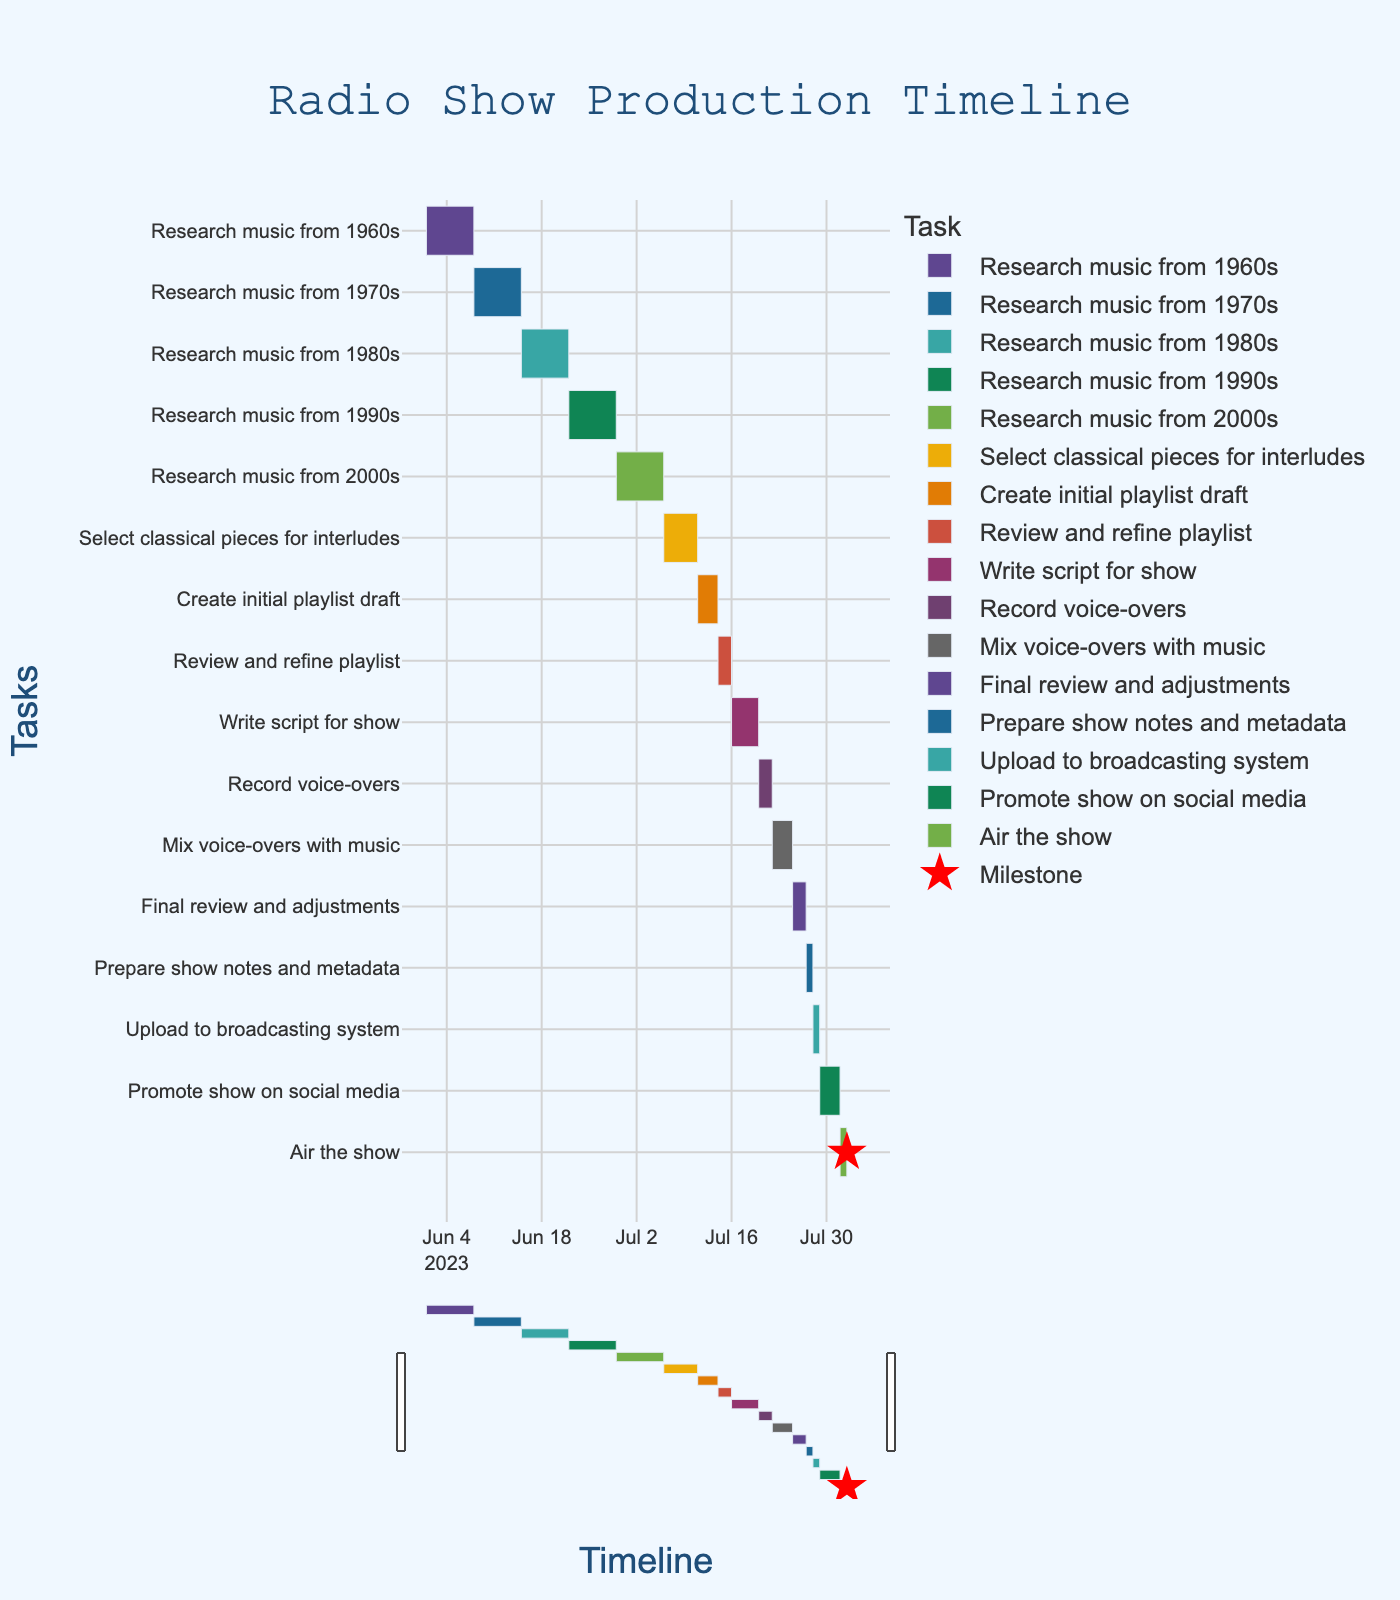What is the title of the figure? The title is located at the top of the Gantt chart and summarizes the overarching theme of the visualization.
Answer: Radio Show Production Timeline When does the task "Research music from 1970s" start? Locate the bar representing "Research music from 1970s" and read its starting position on the timeline.
Answer: 2023-06-08 How many days are allocated for the task "Write script for show"? Identify the bar corresponding to "Write script for show" and check its duration.
Answer: 4 days Which task has the shortest duration and what is it? Examine the lengths of all bars to find the shortest one and identify its task.
Answer: Prepare show notes and metadata (1 day) How long is the total duration from the start of the first task to the end of the last task? Find the start date of the first task and the end date of the last task, then calculate the duration between these two dates. The first task starts on 2023-06-01, and the last task ends on 2023-08-01.
Answer: 62 days Which phase of the production includes the milestone marker? Identify the task associated with the star marker in the Gantt chart, which represents a milestone.
Answer: Air the show What is the combined duration of the research tasks for all decades included in the show? Add up the durations of the tasks labeled "Research music from 1960s" through "Research music from 2000s". Each research task is 7 days long, and there are 5 such tasks. (7 days * 5 tasks = 35 days)
Answer: 35 days When does the task "Mix voice-overs with music" end? Locate the bar for "Mix voice-overs with music" and determine its endpoint. The task starts on 2023-07-22 and lasts 3 days, ending on 2023-07-25.
Answer: 2023-07-25 Which tasks have overlapping timelines with the task "Write script for show"? Identify the timeline for "Write script for show" and compare it with other tasks to see which ones overlap. "Write script for show" is from 2023-07-16 to 2023-07-20. The overlapping tasks are "Record voice-overs" which starts on 2023-07-20.
Answer: Record voice-overs What color is used to represent the task "Upload to broadcasting system"? Look at the color-coded bars on the Gantt chart and identify the specific color of the task "Upload to broadcasting system".
Answer: [Color of "Upload to broadcasting system" as shown in the Gantt chart] 